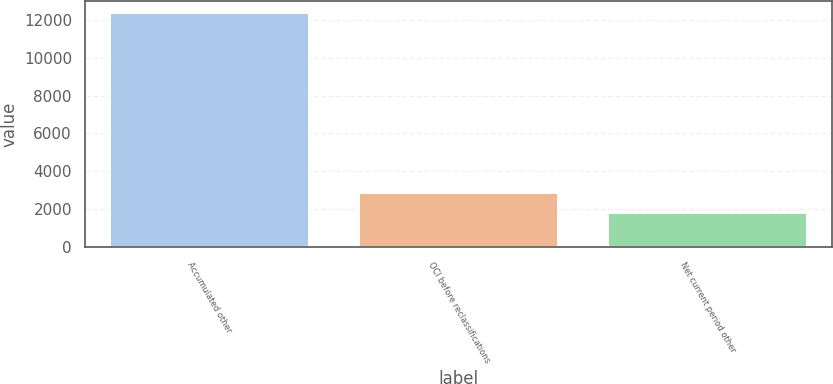<chart> <loc_0><loc_0><loc_500><loc_500><bar_chart><fcel>Accumulated other<fcel>OCI before reclassifications<fcel>Net current period other<nl><fcel>12371<fcel>2854.4<fcel>1797<nl></chart> 